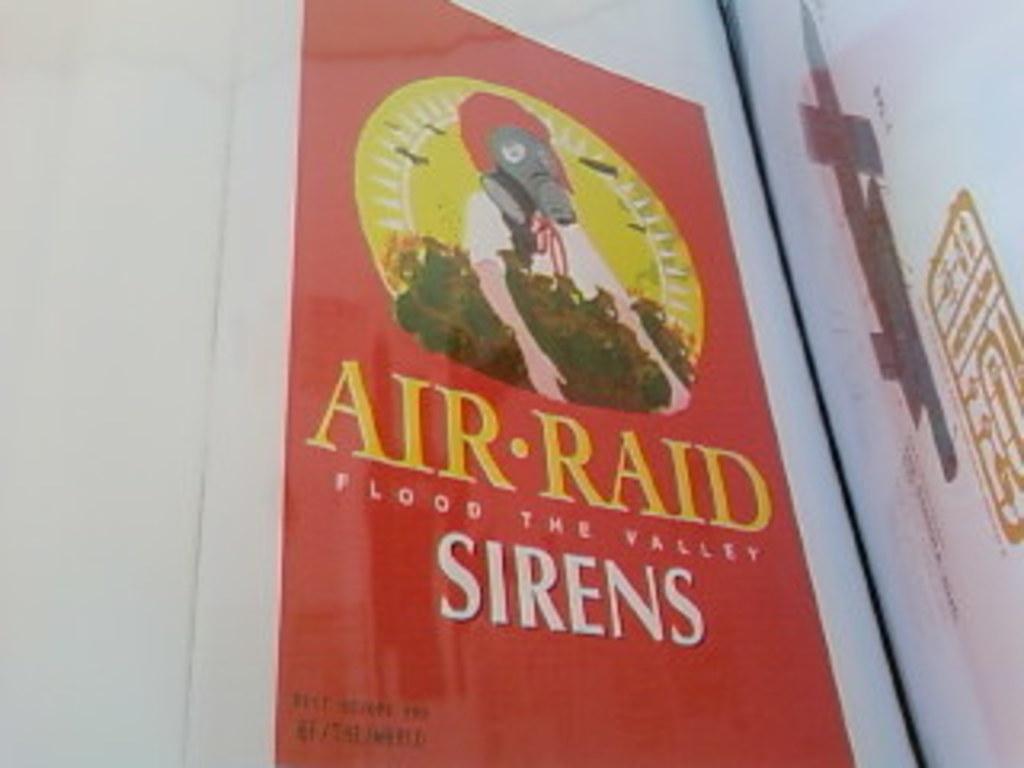What does aır-raid do?
Offer a very short reply. Flood the valley. 